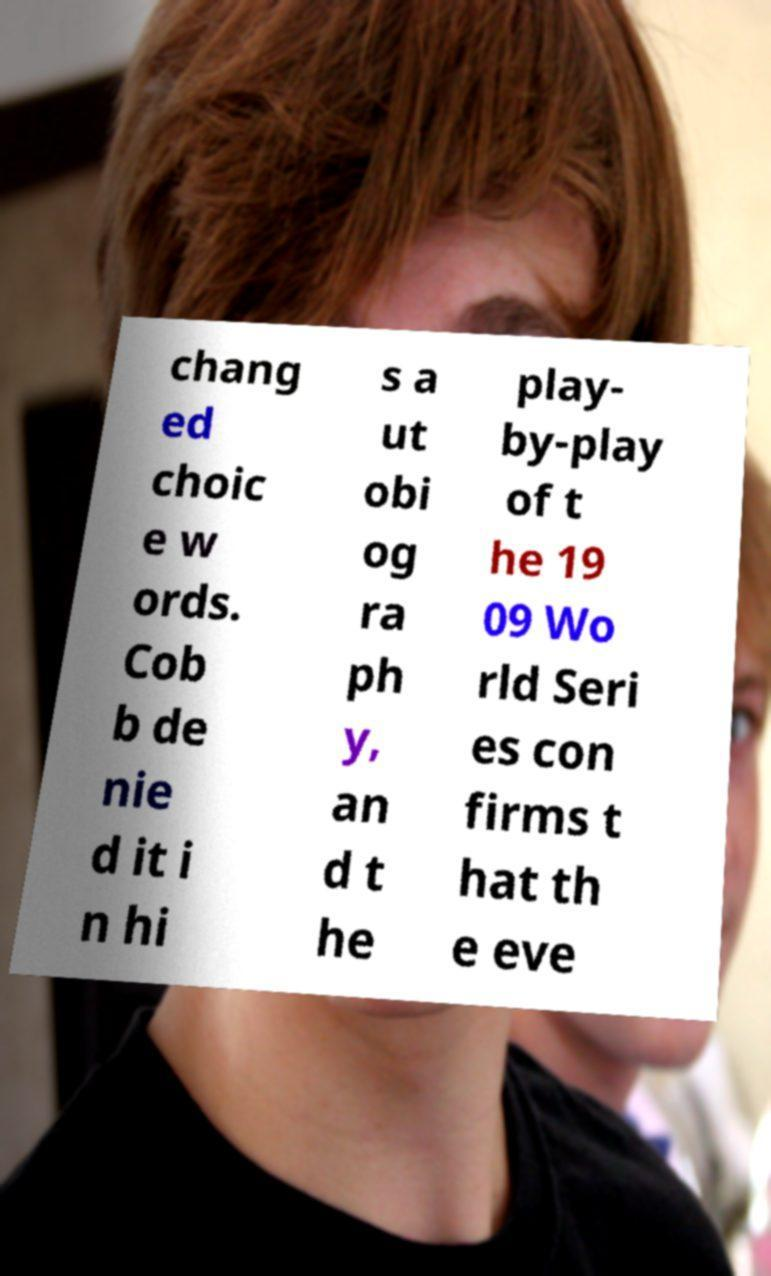Please read and relay the text visible in this image. What does it say? chang ed choic e w ords. Cob b de nie d it i n hi s a ut obi og ra ph y, an d t he play- by-play of t he 19 09 Wo rld Seri es con firms t hat th e eve 